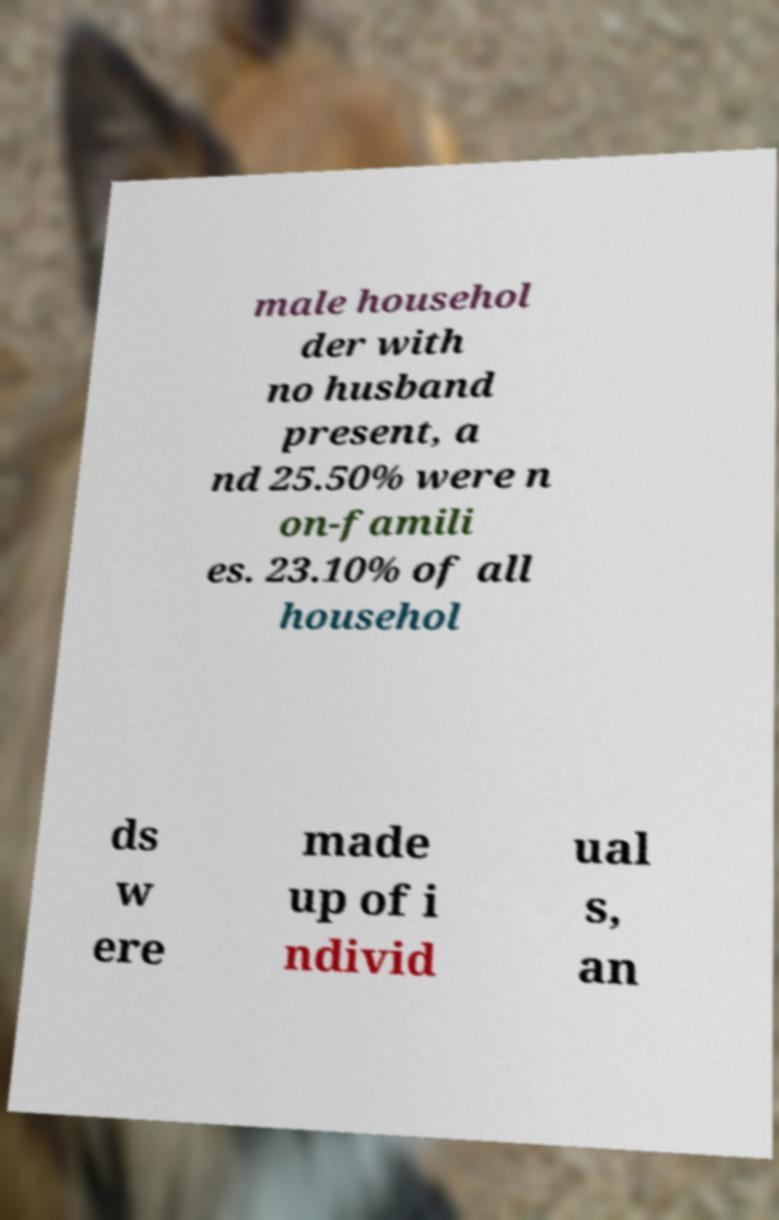Can you accurately transcribe the text from the provided image for me? male househol der with no husband present, a nd 25.50% were n on-famili es. 23.10% of all househol ds w ere made up of i ndivid ual s, an 